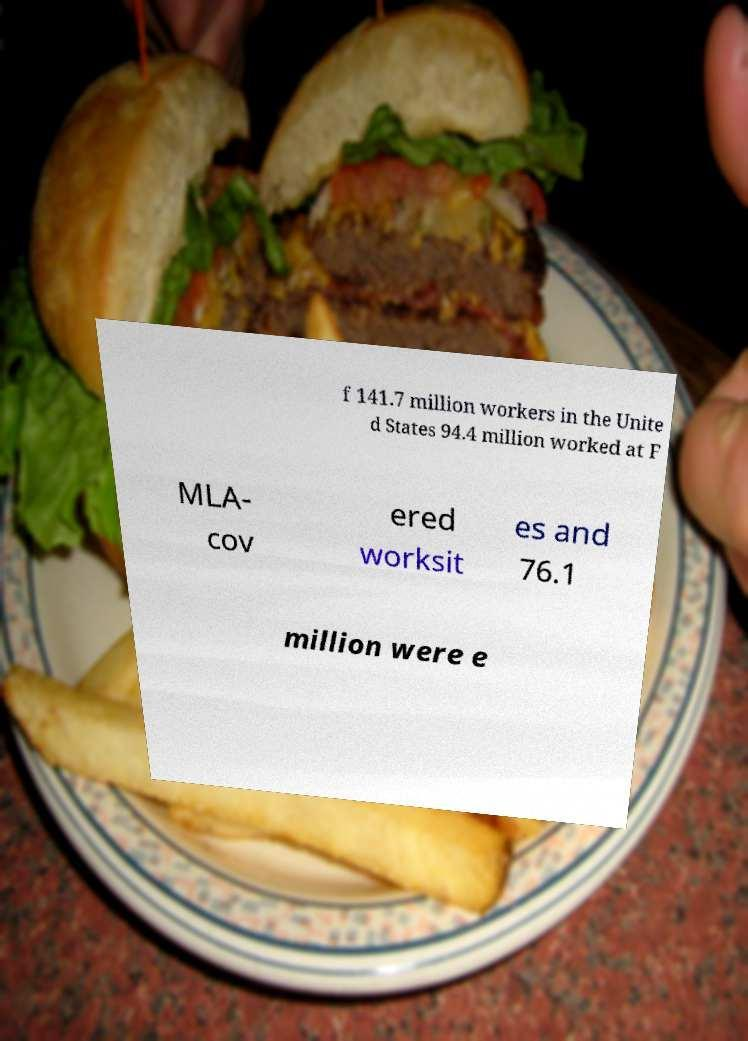There's text embedded in this image that I need extracted. Can you transcribe it verbatim? f 141.7 million workers in the Unite d States 94.4 million worked at F MLA- cov ered worksit es and 76.1 million were e 